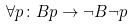Convert formula to latex. <formula><loc_0><loc_0><loc_500><loc_500>\forall p \colon B p \rightarrow \neg B \neg p</formula> 